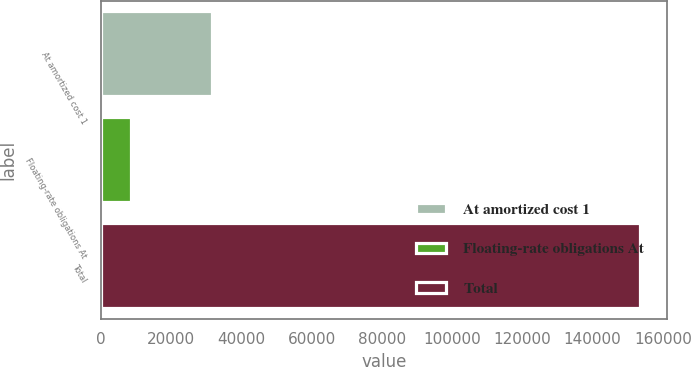Convert chart to OTSL. <chart><loc_0><loc_0><loc_500><loc_500><bar_chart><fcel>At amortized cost 1<fcel>Floating-rate obligations At<fcel>Total<nl><fcel>31741<fcel>8671<fcel>153513<nl></chart> 